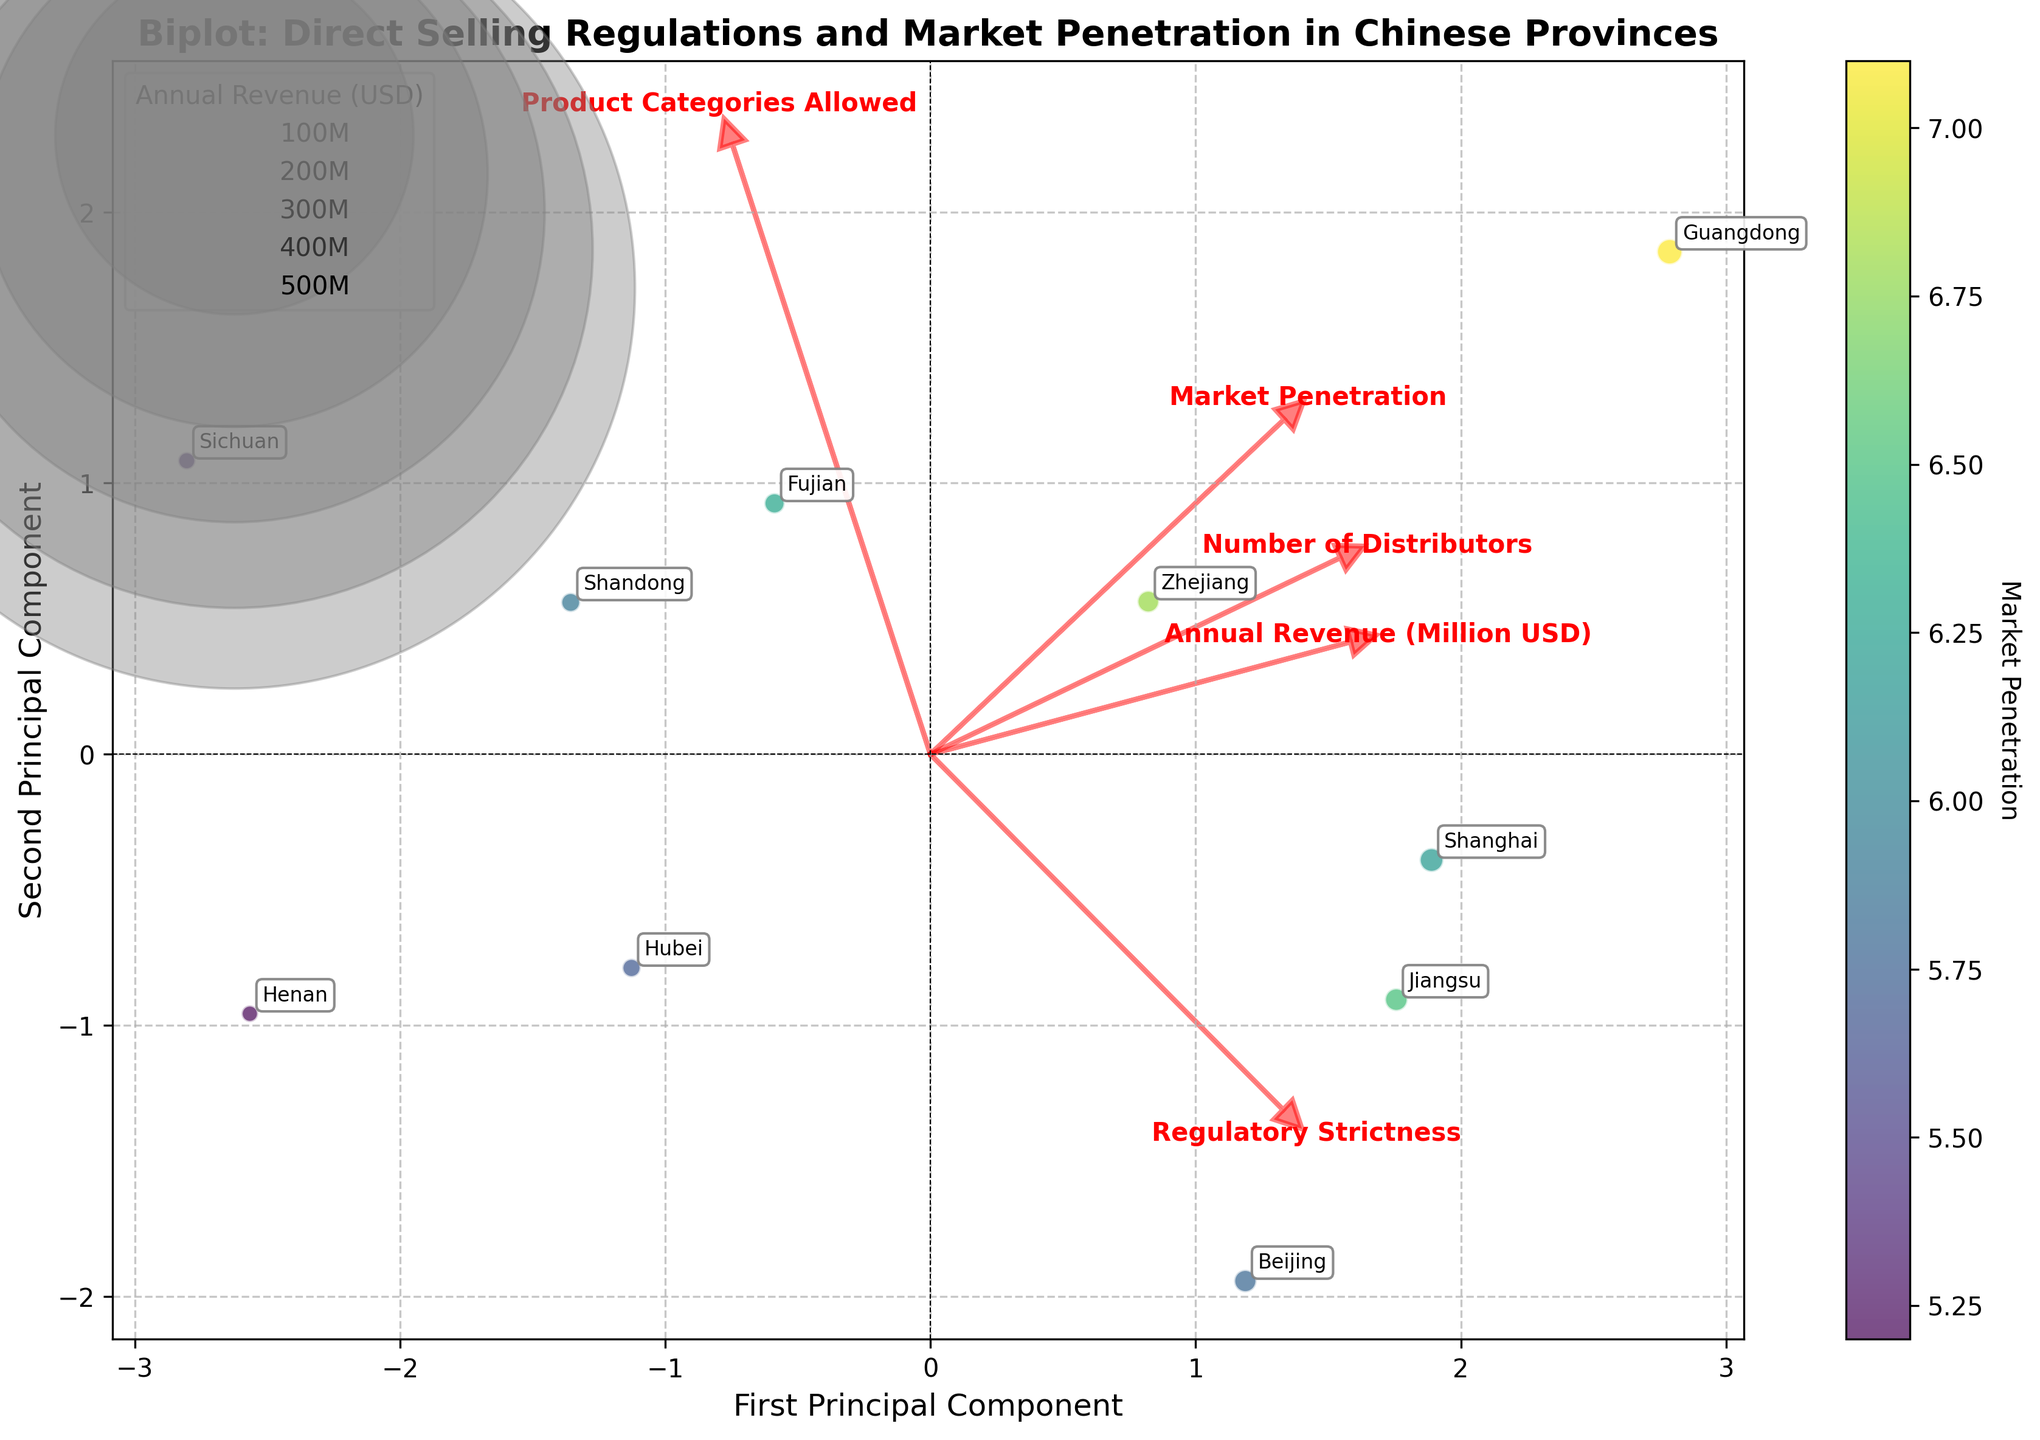What does the title of the figure indicate? The title of the figure provides an overview of the content, indicating it is a Biplot comparing direct selling regulations and market penetration in various Chinese provinces.
Answer: Biplot: Direct Selling Regulations and Market Penetration in Chinese Provinces Which province has the highest market penetration according to the color scale? Looking at the color scale and the data points, Guangdong (colored in the darkest shade) shows the highest market penetration.
Answer: Guangdong What are the labels on the x-axis and y-axis? The x-axis represents the first principal component, and the y-axis represents the second principal component. These axes summarize the main variations in the data.
Answer: First Principal Component, Second Principal Component How does the number of distributors relate to the bubble sizes in the plot? Larger bubble sizes indicate a higher number of distributors in the province, as the bubble size is proportional to the number of distributors.
Answer: Proportional to number of distributors Which provinces have more than 3 allowed product categories and also show high market penetration? The provinces with more than 3 allowed product categories showing high market penetration (darker colors) are Guangdong, Fujian, Shandong, and Zhejiang. These have more than 3 product categories and are colored darker than others.
Answer: Guangdong, Fujian, Shandong, Zhejiang Which province appears closest to the origin on the Biplot? By observing the proximity of points to the origin (0,0) in the PCA space, Shandong seems closest to the origin.
Answer: Shandong Identify the province with the highest regulatory strictness and describe its impact on market penetration. Beijing has the highest regulatory strictness (8.7) but its market penetration is moderate (5.8), as shown by its position in the plot with a relatively lighter color shade compared to Guangdong and Fujian.
Answer: Beijing; high regulatory strictness, moderate market penetration Which features are most strongly associated with the first principal component and the second principal component? By observing the feature vectors' lengths and directions, 'Regulatory Strictness' and 'Market Penetration' are highly associated with the first principal component, and 'Annual Revenue' and 'Number of Distributors' with the second principal component.
Answer: First PC: Regulatory Strictness, Market Penetration; Second PC: Annual Revenue, Number of Distributors Can you identify a trend between annual revenue and market penetration among the provinces? Generally, provinces with higher market penetration tend to have higher annual revenue, indicated by the larger bubble sizes in darker colored points situated towards the center-right of the plot.
Answer: Higher market penetration, higher annual revenue Which vector points in the same direction as the 'Market Penetration' feature vector? Observing the red arrows, the 'Number of Distributors' feature vector closely follows the same path as the 'Market Penetration' feature vector, suggesting a positive correlation.
Answer: Number of Distributors 